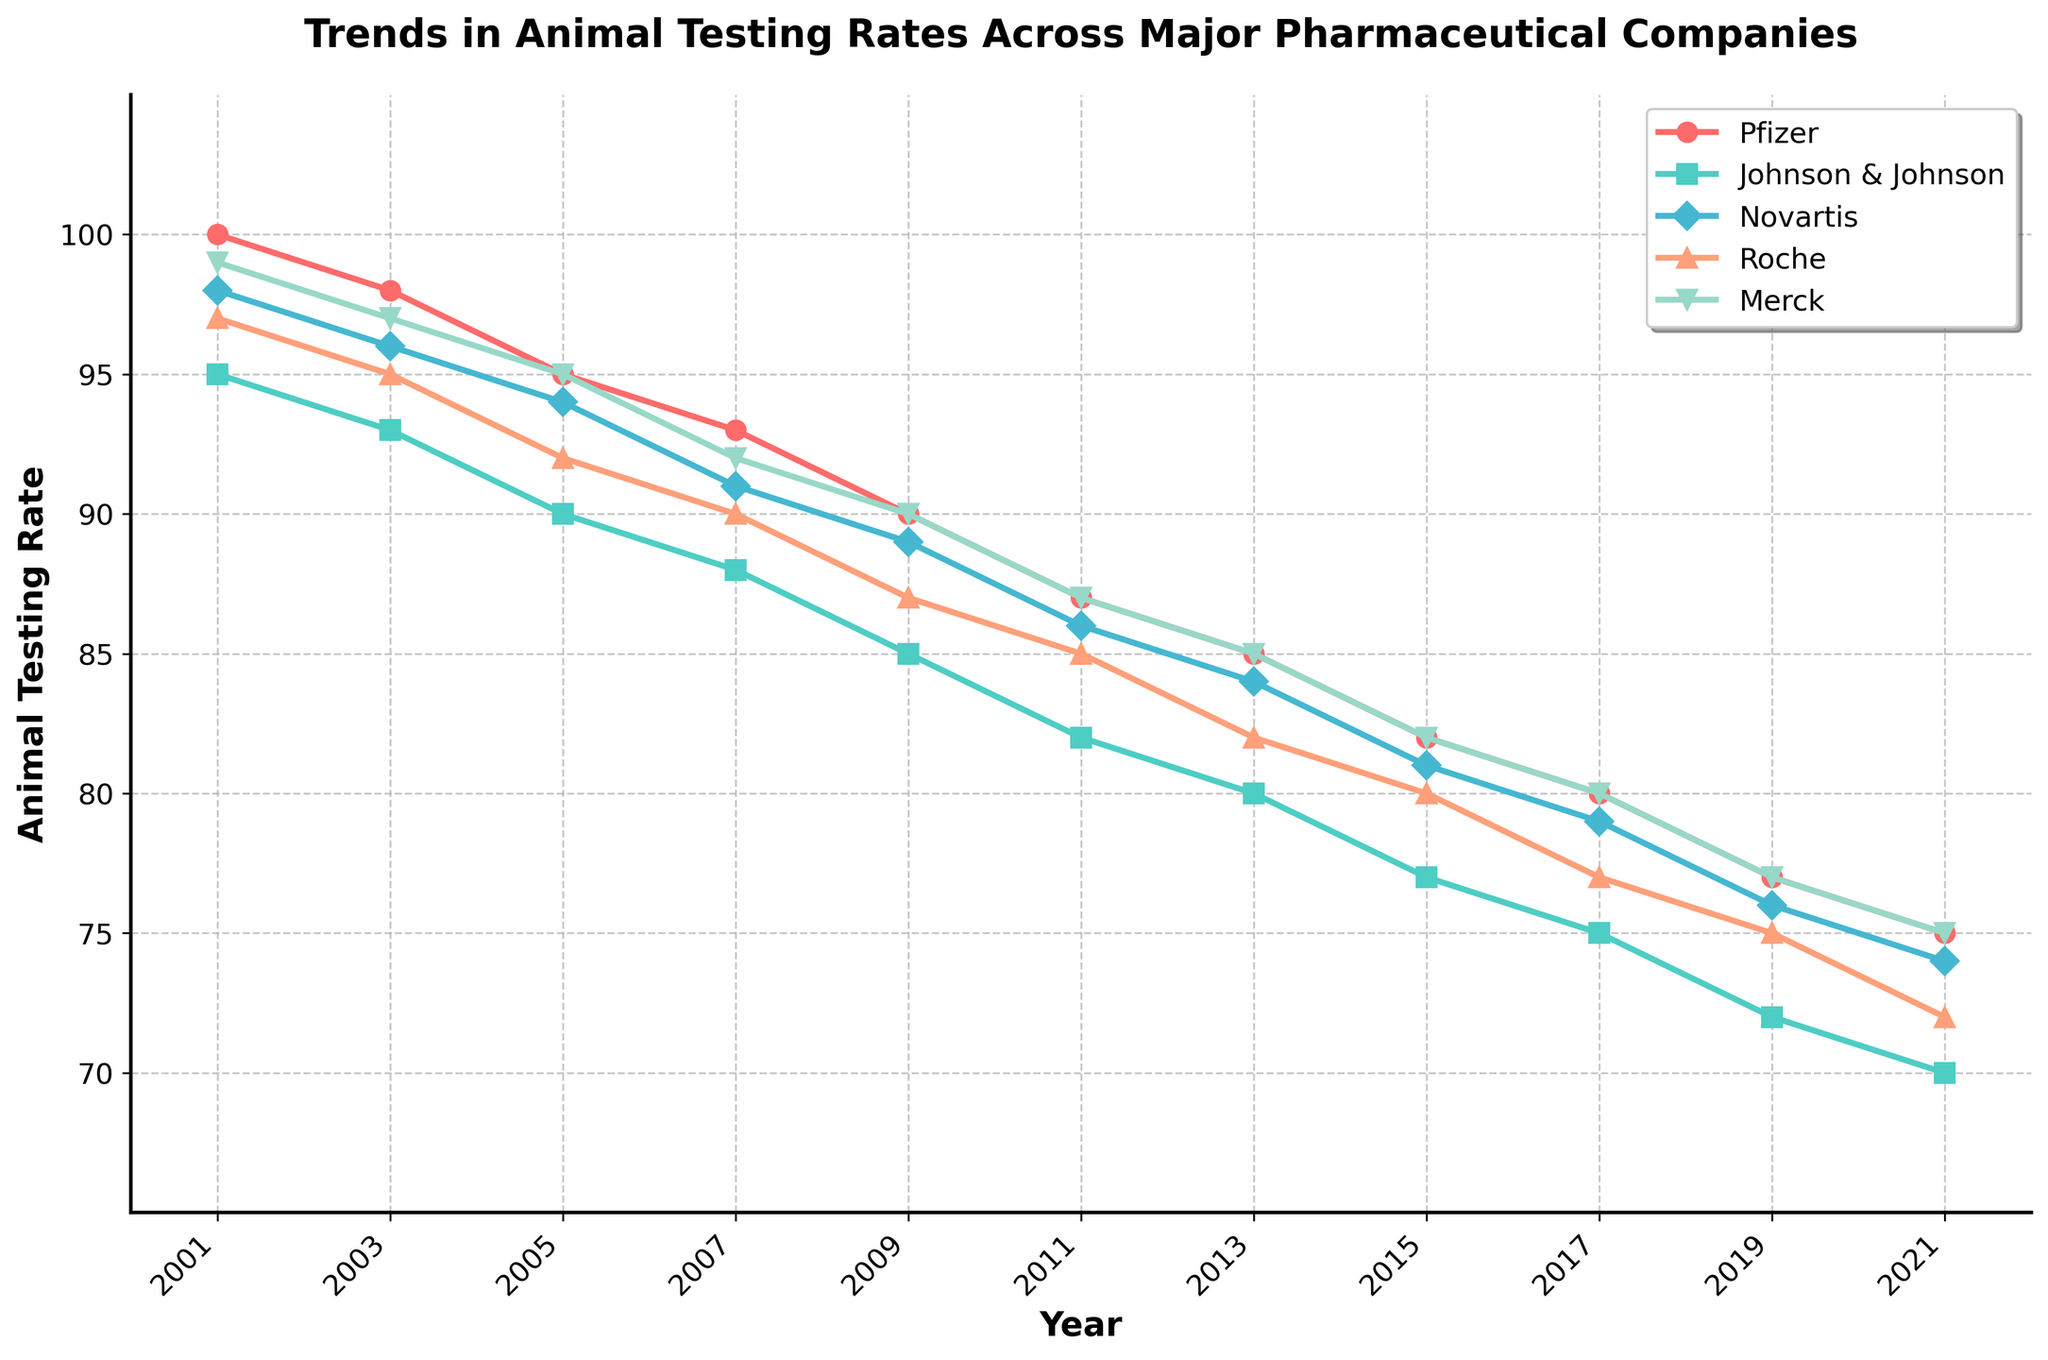Which company had the highest animal testing rate in 2005? To find the company with the highest animal testing rate in 2005, look at the rates for all companies in that year. Pfizer had a rate of 95, Johnson & Johnson 90, Novartis 94, Roche 92, and Merck 95. The highest value is 95, which is shared by Pfizer and Merck.
Answer: Pfizer and Merck Which company's animal testing rate decreased the most from 2001 to 2021? To determine which company had the largest decrease, calculate the difference between the rates in 2001 and 2021 for each company. Pfizer: 100 - 75 = 25, Johnson & Johnson: 95 - 70 = 25, Novartis: 98 - 74 = 24, Roche: 97 - 72 = 25, Merck: 99 - 75 = 24. The largest decrease is 25, shared by Pfizer, Johnson & Johnson, and Roche.
Answer: Pfizer, Johnson & Johnson, and Roche What is the overall trend in animal testing rates for all companies over the 20 years? Observe the general direction of the lines representing each company from 2001 to 2021. All lines show a downward trend, indicating that animal testing rates for all companies have decreased over the 20-year period.
Answer: Decreasing From 2001 to 2011, which company showed the least reduction in animal testing rate? Calculate the reduction for each company from 2001 to 2011. Pfizer: 100 - 87 = 13, Johnson & Johnson: 95 - 82 = 13, Novartis: 98 - 86 = 12, Roche: 97 - 85 = 12, Merck: 99 - 87 = 12. The least reduction is 12, observed for Novartis, Roche, and Merck.
Answer: Novartis, Roche, and Merck Which two companies had identical rates at any point during the time period? Look for points where the lines representing different companies intersect. In 2001 and 2005, Pfizer and Merck had identical rates (100 in 2001 and 95 in 2005). Also, in 2011, Roche and Merck both had rates of 85.
Answer: Pfizer and Merck; Roche and Merck By how much did Novartis's animal testing rate change between 2005 and 2019? Calculate the difference in Novartis's rate between 2005 and 2019. The rate in 2005 was 94 and in 2019 was 76. The change is 94 - 76 = 18.
Answer: 18 What was the average animal testing rate for Johnson & Johnson over the entire time period? Sum the rates for Johnson & Johnson from 2001 to 2021 and divide by the number of years. (95 + 93 + 90 + 88 + 85 + 82 + 80 + 77 + 75 + 72 + 70) / 11 = 82.27.
Answer: 82.27 Which company had the consistently lowest animal testing rate from 2015 to 2021? Compare the rates for each year from 2015 to 2021 for all companies. Johnson & Johnson had the lowest rates each of those years: 77, 75, 72, and 70.
Answer: Johnson & Johnson If Pfizer's rate trends continued beyond 2021, what would be a reasonable estimate for its rate in 2023? Analyze the trend for Pfizer, which shows a consistent decrease approximately every two years. The rate decreased by 2 from 2019 to 2021. If this trend continued, the 2023 rate would likely be 75 - 2 = 73.
Answer: 73 